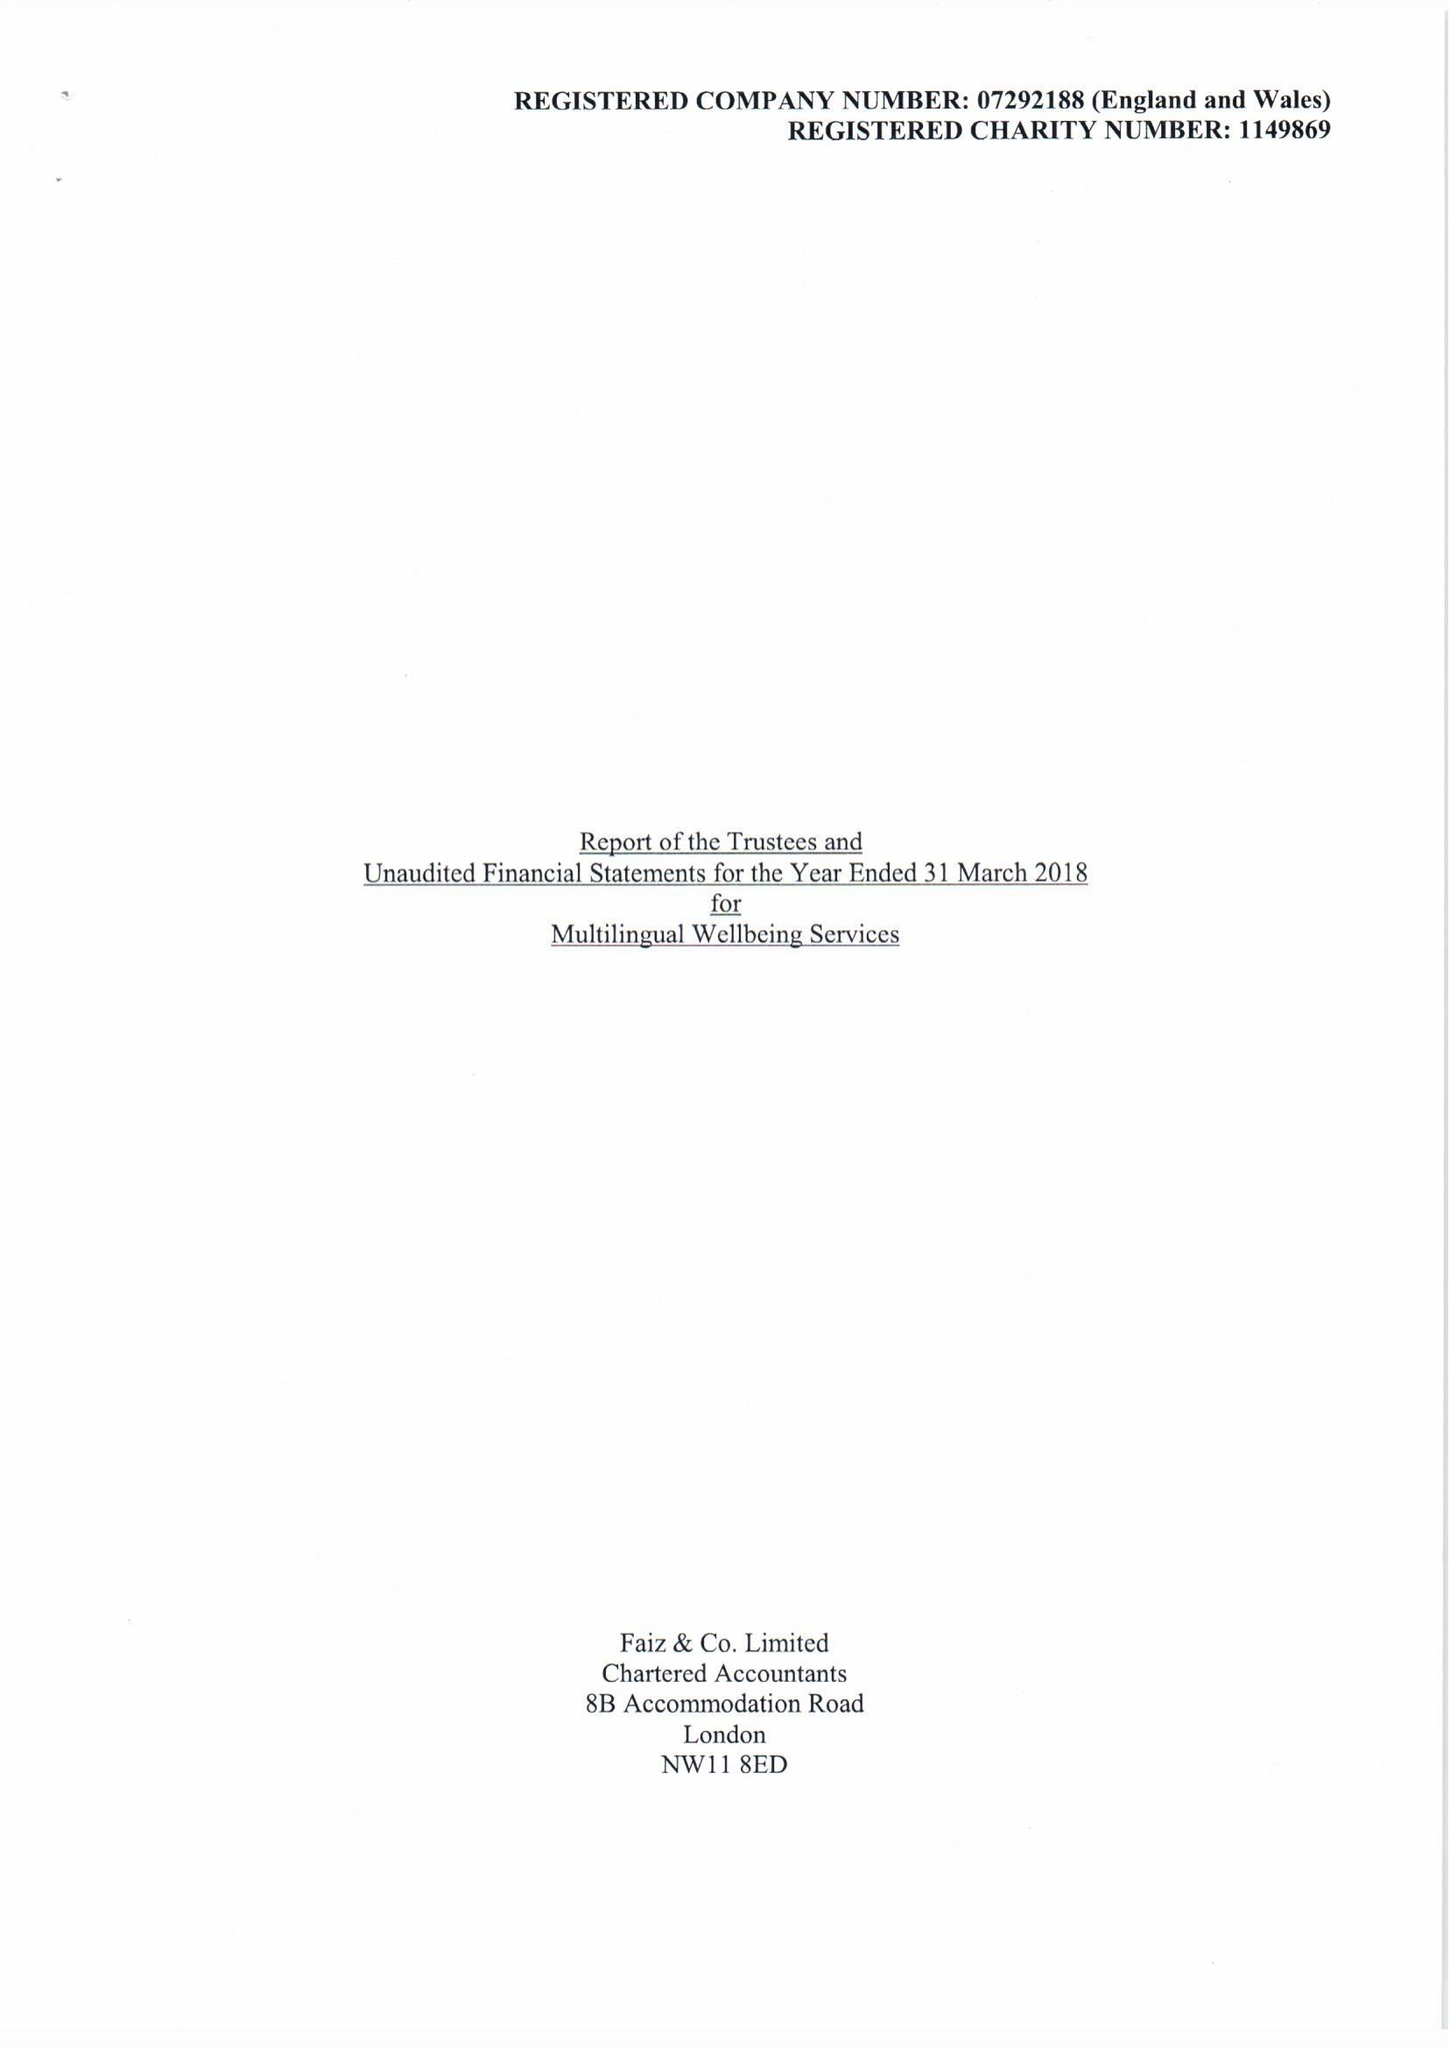What is the value for the address__street_line?
Answer the question using a single word or phrase. BURNT OAK BROADWAY 